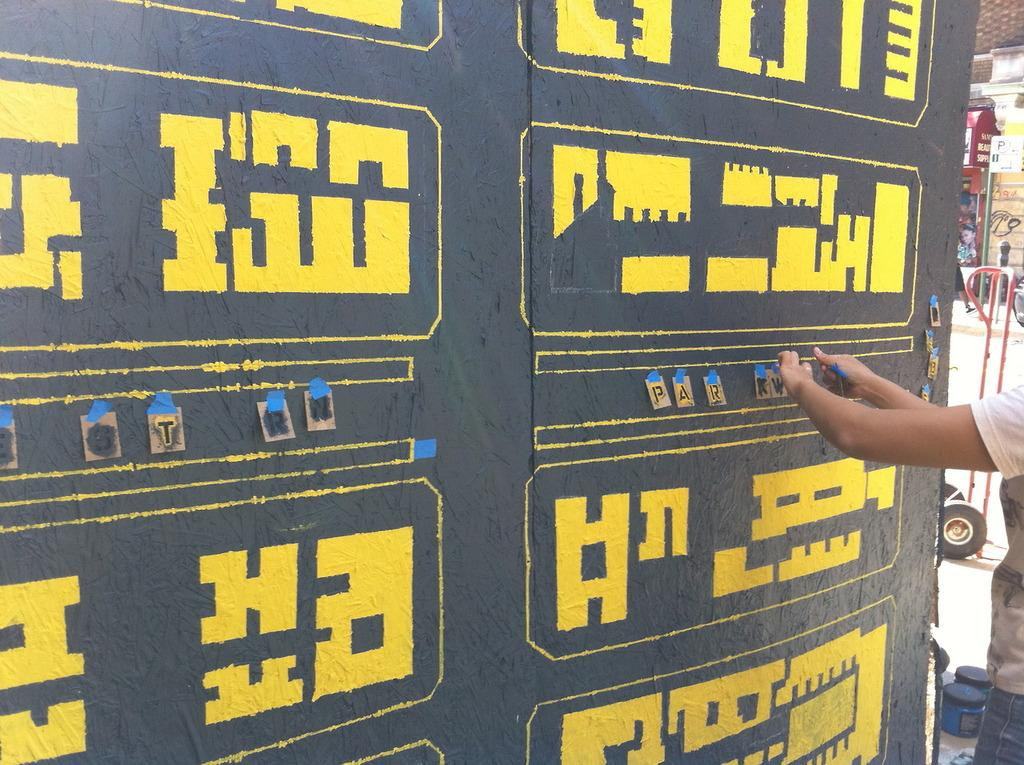What is the main structure in the center of the image? There is a wall in the center of the image. What can be seen on the right side of the image? There is a road on the right side of the image. Is there anyone present near the road? Yes, there is a person standing on the road. What type of sound can be heard coming from the wall in the image? There is no sound coming from the wall in the image, as it is a static structure. 